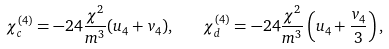Convert formula to latex. <formula><loc_0><loc_0><loc_500><loc_500>\chi _ { c } ^ { ( 4 ) } = - 2 4 { \frac { \chi ^ { 2 } } { m ^ { 3 } } } ( u _ { 4 } + v _ { 4 } ) , \quad \chi _ { d } ^ { ( 4 ) } = - 2 4 { \frac { \chi ^ { 2 } } { m ^ { 3 } } } \left ( u _ { 4 } + { \frac { v _ { 4 } } { 3 } } \right ) , \\</formula> 